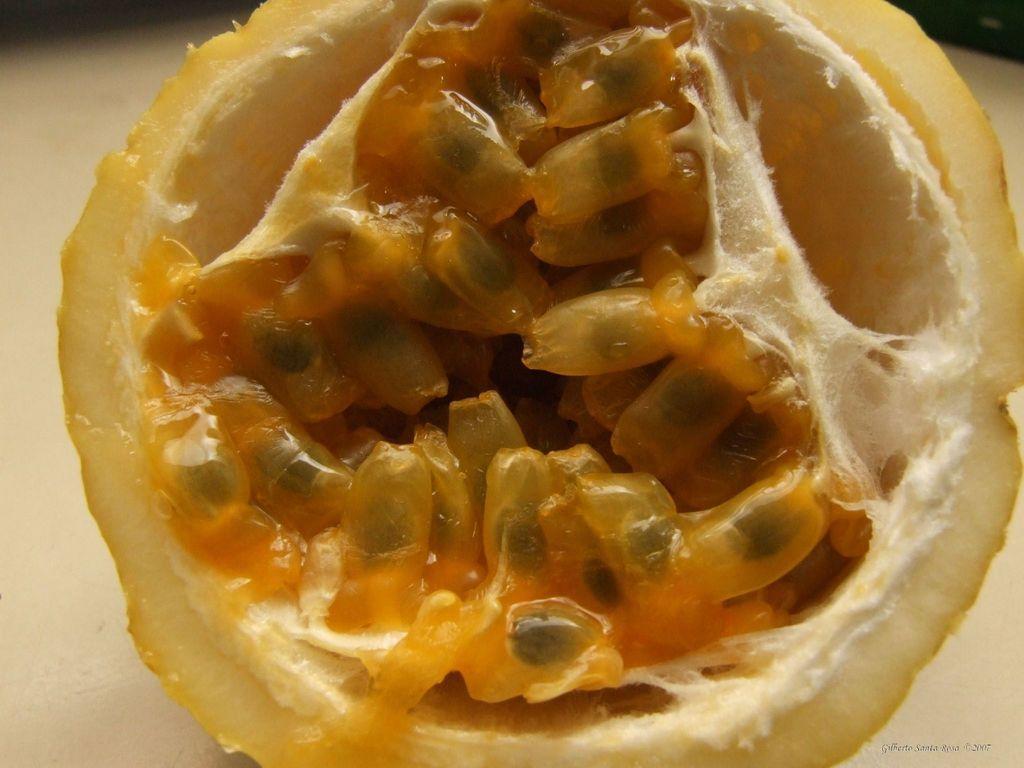Please provide a concise description of this image. In this picture we can see a fruit slice, there is a blurry background. 